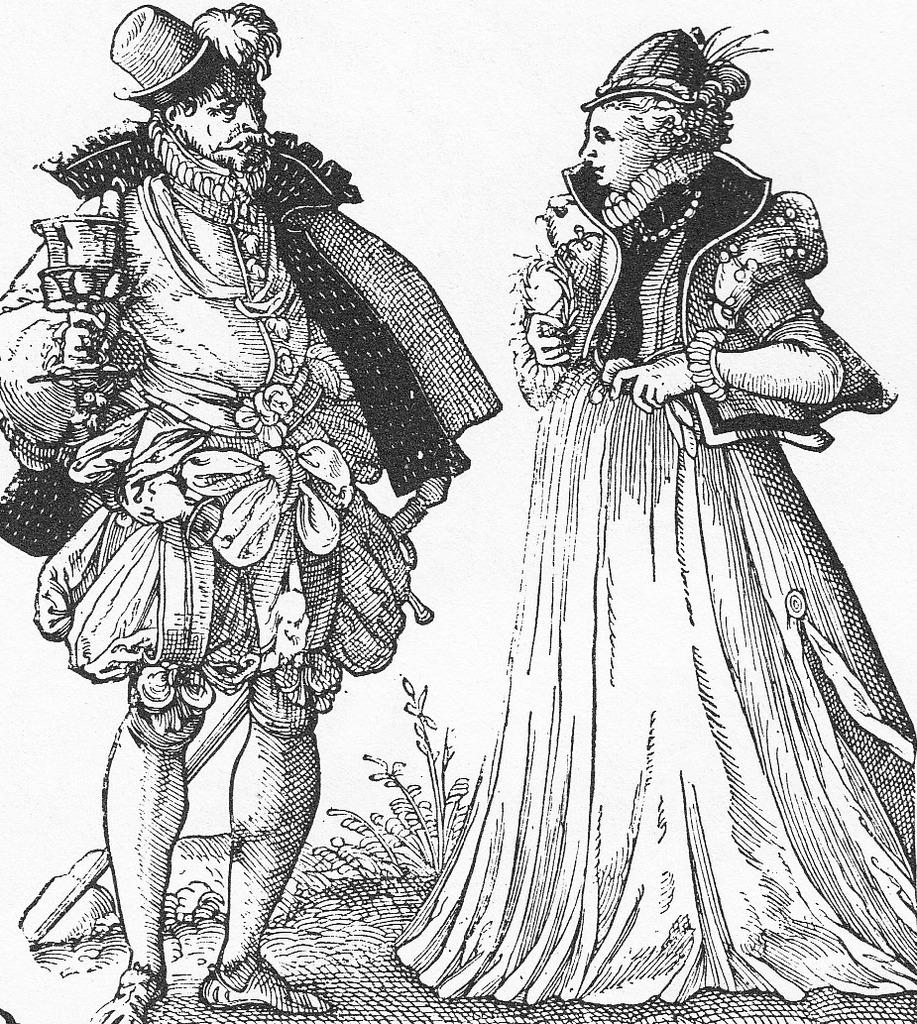What is depicted in the image? There is a sketch of a person in the image. What is the person holding in the sketch? The person is holding objects in the sketch. What other element can be seen in the image? There is a plant in the image. What color is the background of the image? The background of the image is white. What type of insurance policy is being discussed in the image? There is no mention of insurance in the image; it features a sketch of a person holding objects, a plant, and a white background. What authority figure is present in the image? There is no authority figure present in the image; it features a sketch of a person holding objects, a plant, and a white background. 